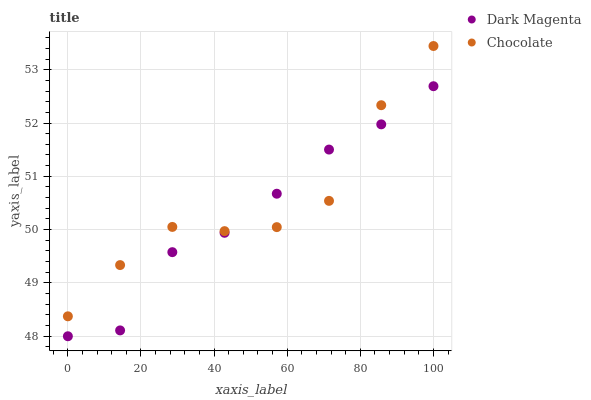Does Dark Magenta have the minimum area under the curve?
Answer yes or no. Yes. Does Chocolate have the maximum area under the curve?
Answer yes or no. Yes. Does Chocolate have the minimum area under the curve?
Answer yes or no. No. Is Dark Magenta the smoothest?
Answer yes or no. Yes. Is Chocolate the roughest?
Answer yes or no. Yes. Is Chocolate the smoothest?
Answer yes or no. No. Does Dark Magenta have the lowest value?
Answer yes or no. Yes. Does Chocolate have the lowest value?
Answer yes or no. No. Does Chocolate have the highest value?
Answer yes or no. Yes. Does Dark Magenta intersect Chocolate?
Answer yes or no. Yes. Is Dark Magenta less than Chocolate?
Answer yes or no. No. Is Dark Magenta greater than Chocolate?
Answer yes or no. No. 